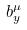Convert formula to latex. <formula><loc_0><loc_0><loc_500><loc_500>b _ { y } ^ { \mu }</formula> 